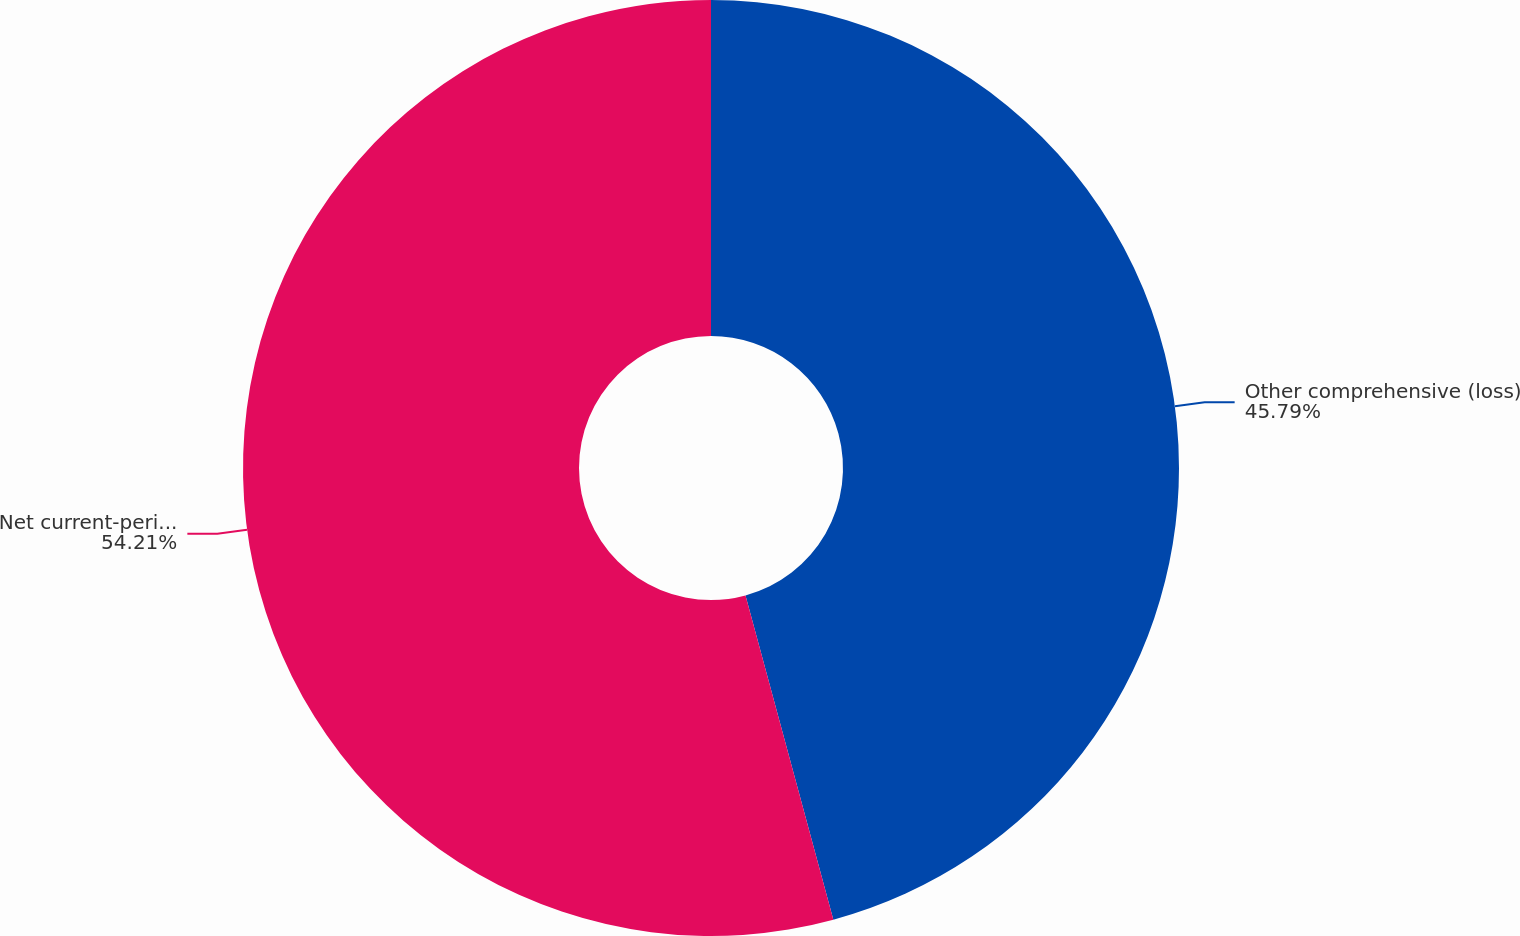Convert chart. <chart><loc_0><loc_0><loc_500><loc_500><pie_chart><fcel>Other comprehensive (loss)<fcel>Net current-period other<nl><fcel>45.79%<fcel>54.21%<nl></chart> 